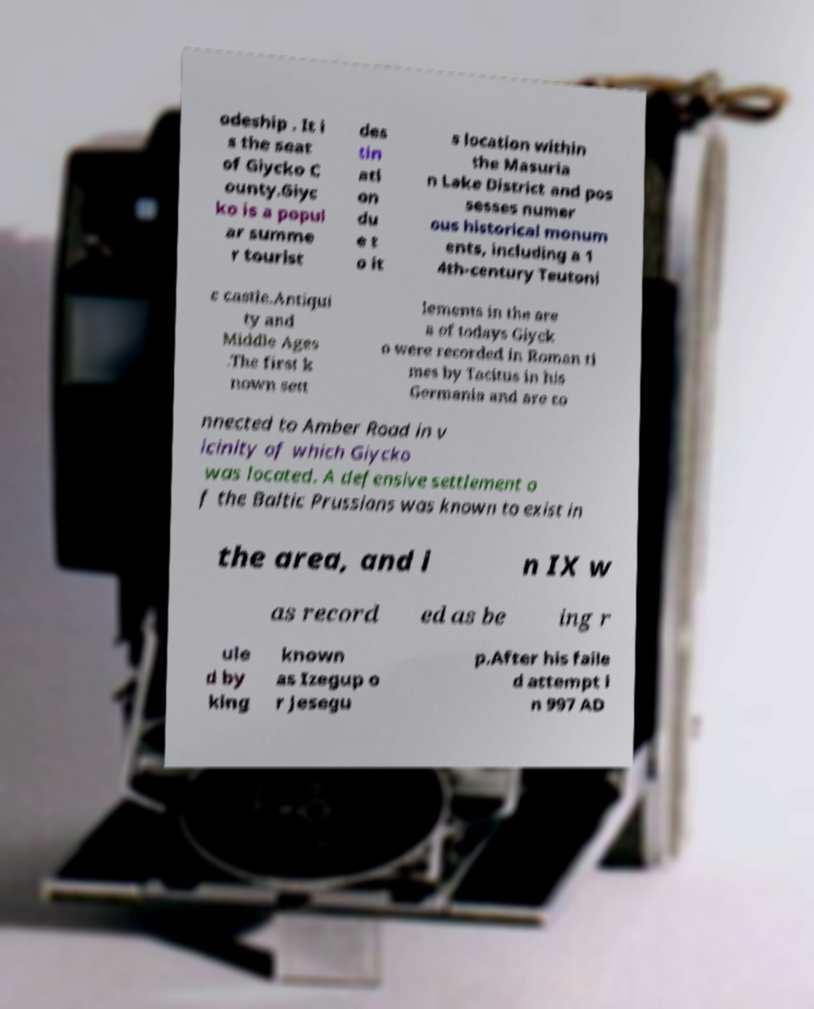Can you accurately transcribe the text from the provided image for me? odeship . It i s the seat of Giycko C ounty.Giyc ko is a popul ar summe r tourist des tin ati on du e t o it s location within the Masuria n Lake District and pos sesses numer ous historical monum ents, including a 1 4th-century Teutoni c castle.Antiqui ty and Middle Ages .The first k nown sett lements in the are a of todays Giyck o were recorded in Roman ti mes by Tacitus in his Germania and are co nnected to Amber Road in v icinity of which Giycko was located. A defensive settlement o f the Baltic Prussians was known to exist in the area, and i n IX w as record ed as be ing r ule d by king known as Izegup o r Jesegu p.After his faile d attempt i n 997 AD 